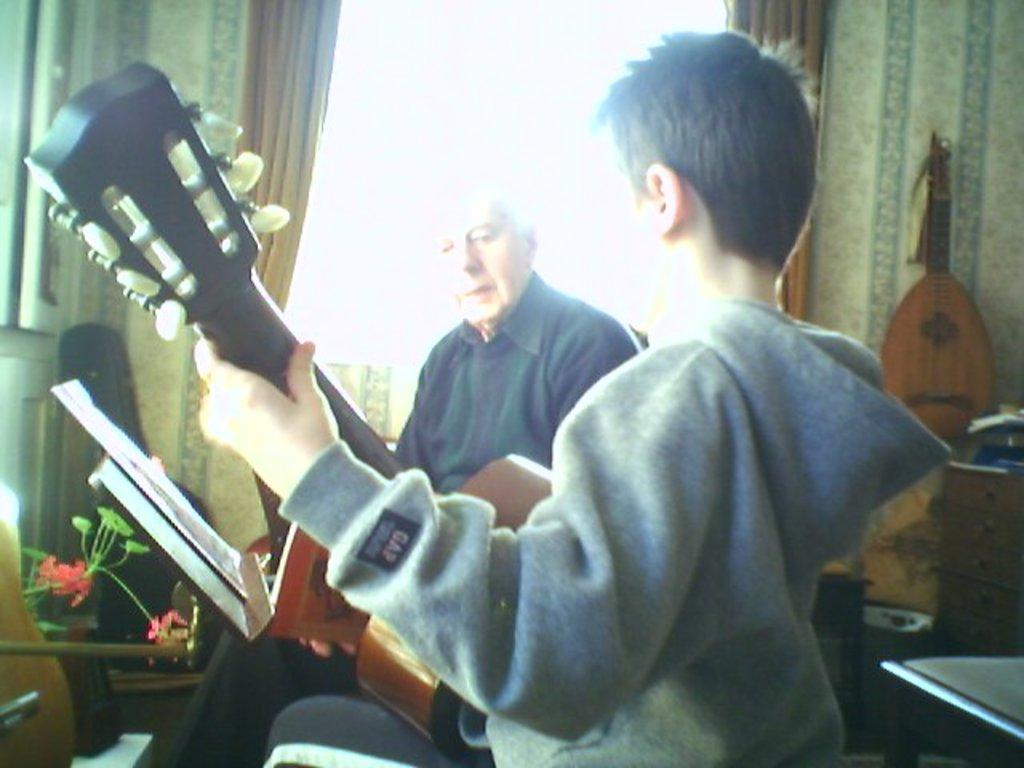How many people are in the image? There are two persons in the image. What are the persons holding in the image? The persons are holding a guitar. What can be seen in the background of the image? There is a curtain and a window in the background of the image. What type of floor can be seen in the image? There is no information about the floor in the image. The focus is on the persons and the guitar they are holding, as well as the background elements. 